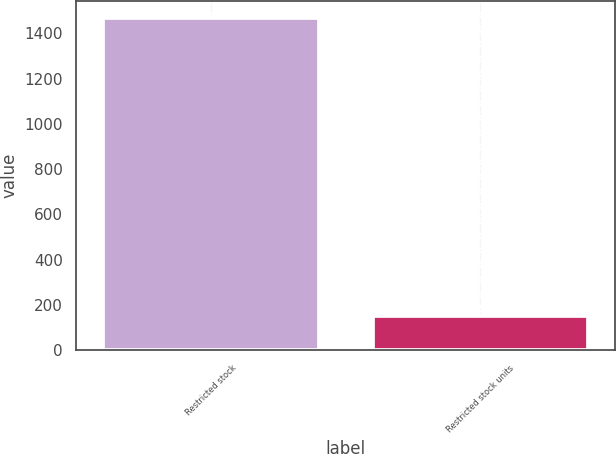Convert chart. <chart><loc_0><loc_0><loc_500><loc_500><bar_chart><fcel>Restricted stock<fcel>Restricted stock units<nl><fcel>1469<fcel>151<nl></chart> 